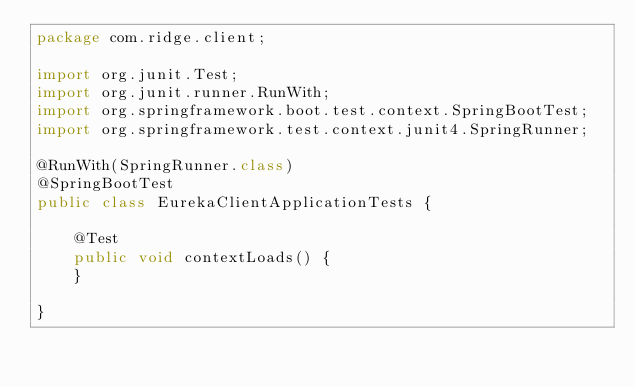<code> <loc_0><loc_0><loc_500><loc_500><_Java_>package com.ridge.client;

import org.junit.Test;
import org.junit.runner.RunWith;
import org.springframework.boot.test.context.SpringBootTest;
import org.springframework.test.context.junit4.SpringRunner;

@RunWith(SpringRunner.class)
@SpringBootTest
public class EurekaClientApplicationTests {

	@Test
	public void contextLoads() {
	}

}
</code> 